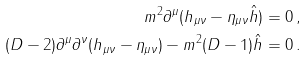Convert formula to latex. <formula><loc_0><loc_0><loc_500><loc_500>m ^ { 2 } \partial ^ { \mu } ( h _ { \mu \nu } - \eta _ { \mu \nu } \hat { h } ) & = 0 \, , \\ ( D - 2 ) \partial ^ { \mu } \partial ^ { \nu } ( h _ { \mu \nu } - \eta _ { \mu \nu } ) - m ^ { 2 } ( D - 1 ) \hat { h } & = 0 \, .</formula> 